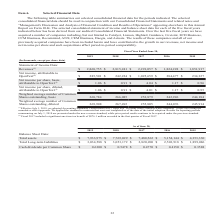According to Opentext Corporation's financial document, What does the table show? summarizes our selected consolidated financial data for the periods indicated. The document states: "The following table summarizes our selected consolidated financial data for the periods indicated. The selected consolidated financial data should be ..." Also, In Fiscal 2017 how much was the tax benefit? According to the financial document, $876.1 million. The relevant text states: "017 included a significant one-time tax benefit of $876.1 million recorded in the first quarter of Fiscal 2017...." Also, What units are used in this table? In thousands, except per share data. The document states: "(In thousands, except per share data)..." Also, can you calculate: What is the Weighted average number of Common Shares outstanding, diluted for years 2017, 2018 and 2019? To answer this question, I need to perform calculations using the financial data. The calculation is: (269,908+267,492+255,805)/3, which equals 264401.67. This is based on the information: "rage number of Common Shares outstanding, diluted 269,908 267,492 255,805 244,076 245,914 ommon Shares outstanding, diluted 269,908 267,492 255,805 244,076 245,914 ber of Common Shares outstanding, di..." The key data points involved are: 255,805, 267,492, 269,908. Also, can you calculate: Excluding the one-tax benefit for Fiscal 2017, what is the Net income, attributable to the company for 2017? Based on the calculation: 1,025,659 thousand-(876.1 million), the result is 149559 (in thousands). This is based on the information: "ttributable to OpenText (2) $ 285,501 $ 242,224 $ 1,025,659 $ 284,477 $ 234,327 Net income per share, basic, attributable to OpenText (1) $ 1.06 $ 0.91 $ 4.04 7 included a significant one-time tax ben..." The key data points involved are: 1,025,659, 876.1. Also, can you calculate: What is the percentage change of Revenues from 2015 to 2019?  To answer this question, I need to perform calculations using the financial data. The calculation is: (2,868,755-1,851,917)/1,851,917, which equals 54.91 (percentage). This is based on the information: "$ 2,868,755 $ 2,815,241 $ 2,291,057 $ 1,824,228 $ 1,851,917 Net income, attributable to OpenText (2) $ 285,501 $ 242,224 $ 1,025,659 $ 284,477 $ 234,327 Net in Statement of Income Data: Revenues (1) $..." The key data points involved are: 1,851,917, 2,868,755. 